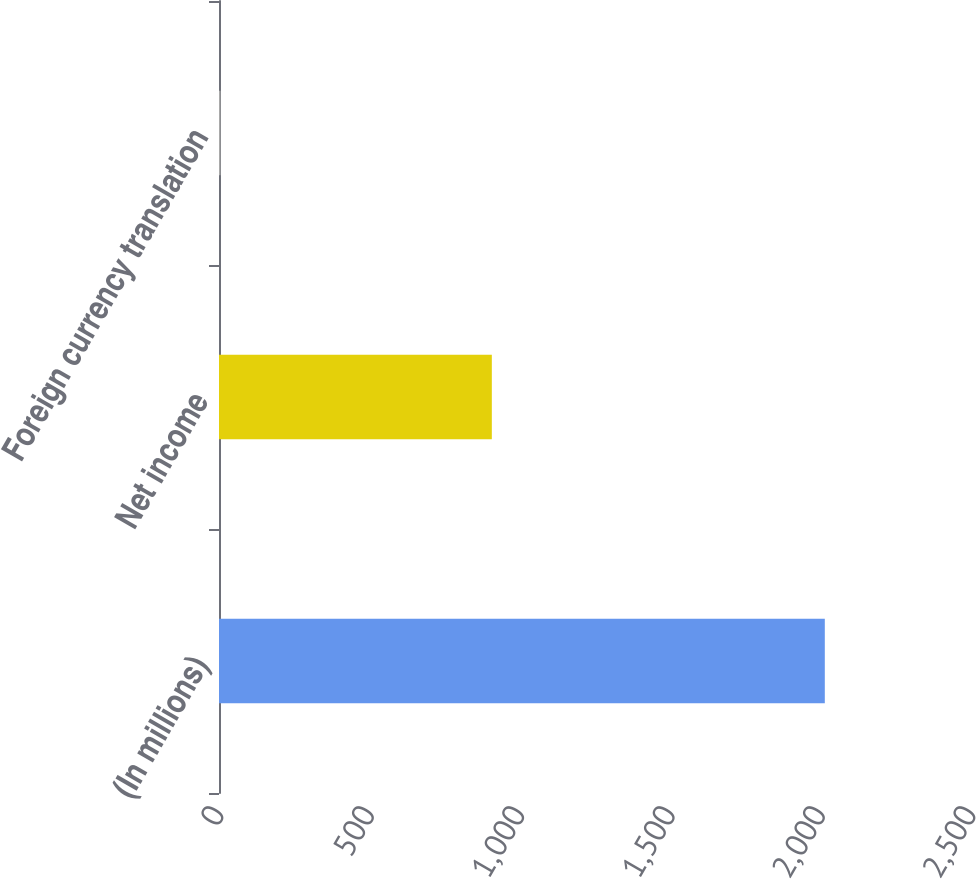Convert chart to OTSL. <chart><loc_0><loc_0><loc_500><loc_500><bar_chart><fcel>(In millions)<fcel>Net income<fcel>Foreign currency translation<nl><fcel>2014<fcel>907<fcel>5<nl></chart> 